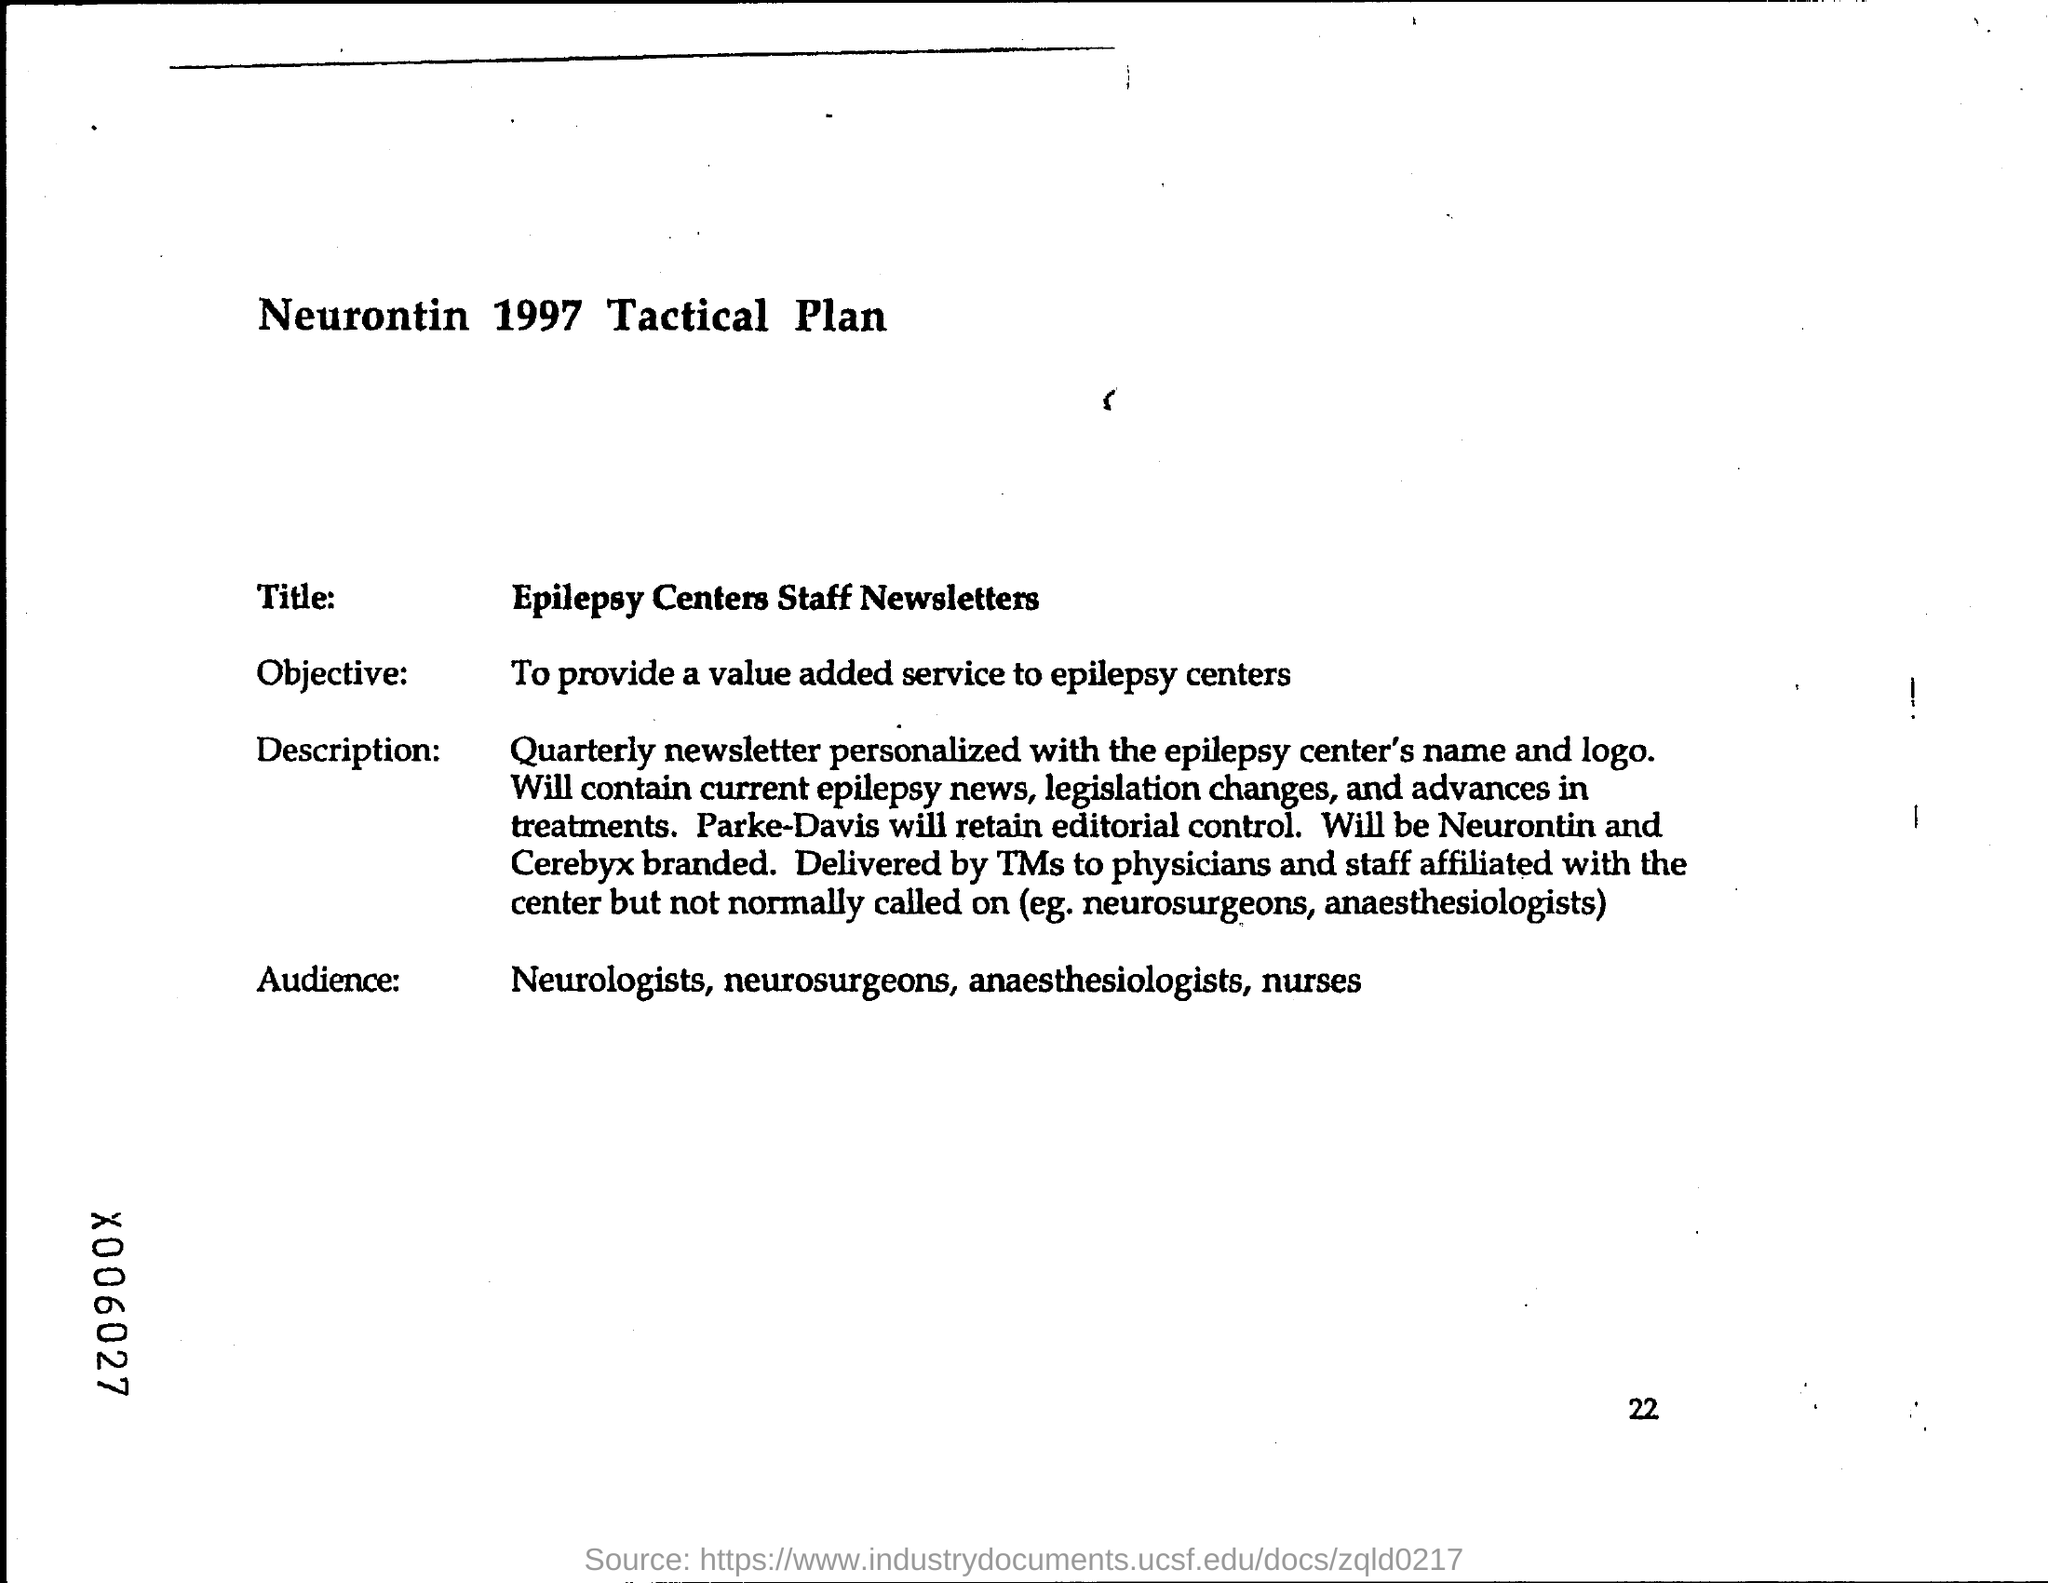What is the title ?
Your answer should be very brief. Epilepsy centers staff newsletters. What is the page number at bottom of the page?
Provide a short and direct response. 22. What is the objective ?
Give a very brief answer. To provide a value added service to epilepsy centers. 